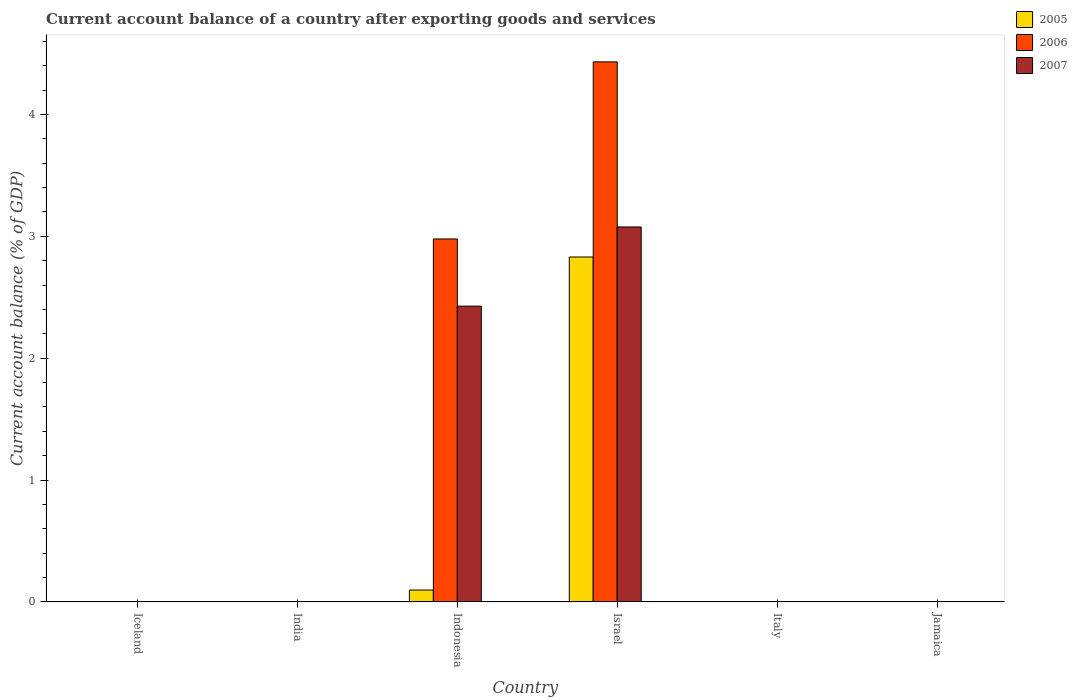How many bars are there on the 1st tick from the left?
Keep it short and to the point. 0. What is the label of the 6th group of bars from the left?
Provide a short and direct response. Jamaica. In how many cases, is the number of bars for a given country not equal to the number of legend labels?
Ensure brevity in your answer.  4. What is the account balance in 2005 in Israel?
Your answer should be compact. 2.83. Across all countries, what is the maximum account balance in 2006?
Give a very brief answer. 4.43. Across all countries, what is the minimum account balance in 2006?
Offer a terse response. 0. In which country was the account balance in 2006 maximum?
Your response must be concise. Israel. What is the total account balance in 2006 in the graph?
Your answer should be compact. 7.41. What is the difference between the account balance in 2005 in Iceland and the account balance in 2006 in Israel?
Your answer should be very brief. -4.43. What is the average account balance in 2005 per country?
Provide a succinct answer. 0.49. What is the difference between the account balance of/in 2006 and account balance of/in 2005 in Indonesia?
Your answer should be compact. 2.88. What is the difference between the highest and the lowest account balance in 2005?
Your answer should be compact. 2.83. In how many countries, is the account balance in 2005 greater than the average account balance in 2005 taken over all countries?
Keep it short and to the point. 1. Is it the case that in every country, the sum of the account balance in 2006 and account balance in 2005 is greater than the account balance in 2007?
Provide a short and direct response. No. What is the difference between two consecutive major ticks on the Y-axis?
Offer a very short reply. 1. Does the graph contain grids?
Provide a succinct answer. No. Where does the legend appear in the graph?
Provide a succinct answer. Top right. What is the title of the graph?
Provide a succinct answer. Current account balance of a country after exporting goods and services. Does "2008" appear as one of the legend labels in the graph?
Your answer should be very brief. No. What is the label or title of the Y-axis?
Ensure brevity in your answer.  Current account balance (% of GDP). What is the Current account balance (% of GDP) of 2007 in India?
Keep it short and to the point. 0. What is the Current account balance (% of GDP) of 2005 in Indonesia?
Your answer should be compact. 0.1. What is the Current account balance (% of GDP) in 2006 in Indonesia?
Provide a short and direct response. 2.98. What is the Current account balance (% of GDP) of 2007 in Indonesia?
Your response must be concise. 2.43. What is the Current account balance (% of GDP) in 2005 in Israel?
Provide a short and direct response. 2.83. What is the Current account balance (% of GDP) in 2006 in Israel?
Your answer should be very brief. 4.43. What is the Current account balance (% of GDP) in 2007 in Israel?
Your answer should be compact. 3.08. What is the Current account balance (% of GDP) of 2006 in Italy?
Your answer should be compact. 0. What is the Current account balance (% of GDP) of 2005 in Jamaica?
Keep it short and to the point. 0. What is the Current account balance (% of GDP) of 2006 in Jamaica?
Your answer should be compact. 0. Across all countries, what is the maximum Current account balance (% of GDP) in 2005?
Ensure brevity in your answer.  2.83. Across all countries, what is the maximum Current account balance (% of GDP) of 2006?
Provide a short and direct response. 4.43. Across all countries, what is the maximum Current account balance (% of GDP) of 2007?
Offer a terse response. 3.08. Across all countries, what is the minimum Current account balance (% of GDP) of 2007?
Provide a short and direct response. 0. What is the total Current account balance (% of GDP) of 2005 in the graph?
Provide a succinct answer. 2.93. What is the total Current account balance (% of GDP) in 2006 in the graph?
Keep it short and to the point. 7.41. What is the total Current account balance (% of GDP) of 2007 in the graph?
Ensure brevity in your answer.  5.5. What is the difference between the Current account balance (% of GDP) of 2005 in Indonesia and that in Israel?
Ensure brevity in your answer.  -2.73. What is the difference between the Current account balance (% of GDP) in 2006 in Indonesia and that in Israel?
Keep it short and to the point. -1.45. What is the difference between the Current account balance (% of GDP) of 2007 in Indonesia and that in Israel?
Provide a succinct answer. -0.65. What is the difference between the Current account balance (% of GDP) in 2005 in Indonesia and the Current account balance (% of GDP) in 2006 in Israel?
Your answer should be very brief. -4.34. What is the difference between the Current account balance (% of GDP) in 2005 in Indonesia and the Current account balance (% of GDP) in 2007 in Israel?
Ensure brevity in your answer.  -2.98. What is the difference between the Current account balance (% of GDP) of 2006 in Indonesia and the Current account balance (% of GDP) of 2007 in Israel?
Ensure brevity in your answer.  -0.1. What is the average Current account balance (% of GDP) in 2005 per country?
Make the answer very short. 0.49. What is the average Current account balance (% of GDP) of 2006 per country?
Ensure brevity in your answer.  1.24. What is the average Current account balance (% of GDP) of 2007 per country?
Ensure brevity in your answer.  0.92. What is the difference between the Current account balance (% of GDP) in 2005 and Current account balance (% of GDP) in 2006 in Indonesia?
Offer a very short reply. -2.88. What is the difference between the Current account balance (% of GDP) in 2005 and Current account balance (% of GDP) in 2007 in Indonesia?
Your answer should be compact. -2.33. What is the difference between the Current account balance (% of GDP) in 2006 and Current account balance (% of GDP) in 2007 in Indonesia?
Your response must be concise. 0.55. What is the difference between the Current account balance (% of GDP) of 2005 and Current account balance (% of GDP) of 2006 in Israel?
Provide a succinct answer. -1.6. What is the difference between the Current account balance (% of GDP) in 2005 and Current account balance (% of GDP) in 2007 in Israel?
Your answer should be compact. -0.25. What is the difference between the Current account balance (% of GDP) of 2006 and Current account balance (% of GDP) of 2007 in Israel?
Keep it short and to the point. 1.35. What is the ratio of the Current account balance (% of GDP) of 2005 in Indonesia to that in Israel?
Ensure brevity in your answer.  0.03. What is the ratio of the Current account balance (% of GDP) of 2006 in Indonesia to that in Israel?
Offer a terse response. 0.67. What is the ratio of the Current account balance (% of GDP) of 2007 in Indonesia to that in Israel?
Offer a very short reply. 0.79. What is the difference between the highest and the lowest Current account balance (% of GDP) in 2005?
Provide a succinct answer. 2.83. What is the difference between the highest and the lowest Current account balance (% of GDP) of 2006?
Your answer should be compact. 4.43. What is the difference between the highest and the lowest Current account balance (% of GDP) of 2007?
Offer a very short reply. 3.08. 